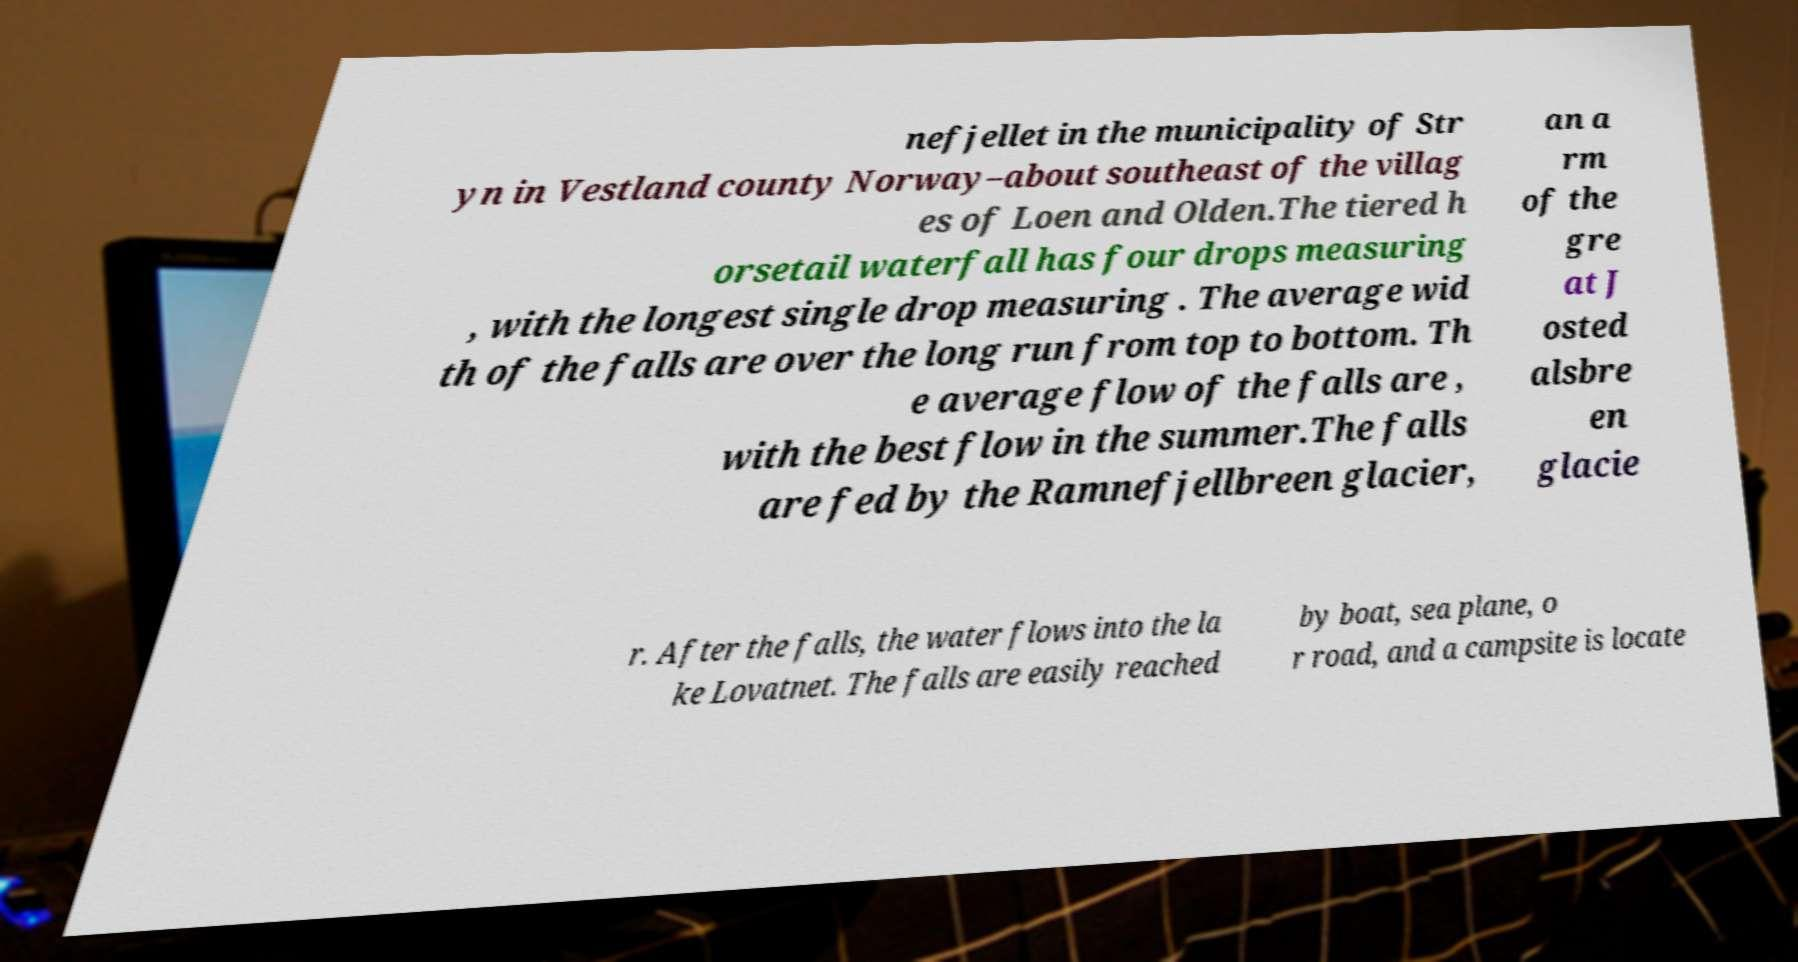Could you assist in decoding the text presented in this image and type it out clearly? nefjellet in the municipality of Str yn in Vestland county Norway–about southeast of the villag es of Loen and Olden.The tiered h orsetail waterfall has four drops measuring , with the longest single drop measuring . The average wid th of the falls are over the long run from top to bottom. Th e average flow of the falls are , with the best flow in the summer.The falls are fed by the Ramnefjellbreen glacier, an a rm of the gre at J osted alsbre en glacie r. After the falls, the water flows into the la ke Lovatnet. The falls are easily reached by boat, sea plane, o r road, and a campsite is locate 